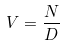<formula> <loc_0><loc_0><loc_500><loc_500>V = \frac { N } { D }</formula> 